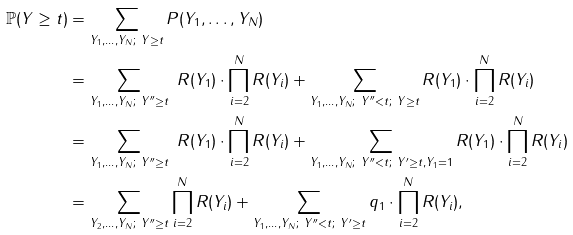<formula> <loc_0><loc_0><loc_500><loc_500>\mathbb { P } ( Y \geq t ) & = \sum _ { Y _ { 1 } , \dots , Y _ { N } ; \ Y \geq t } P ( Y _ { 1 } , \dots , Y _ { N } ) \\ & = \sum _ { Y _ { 1 } , \dots , Y _ { N } ; \ Y ^ { \prime \prime } \geq t } \ R ( Y _ { 1 } ) \cdot \prod _ { i = 2 } ^ { N } R ( Y _ { i } ) + \sum _ { Y _ { 1 } , \dots , Y _ { N } ; \ Y ^ { \prime \prime } < t ; \ Y \geq t } R ( Y _ { 1 } ) \cdot \prod _ { i = 2 } ^ { N } R ( Y _ { i } ) \\ & = \sum _ { Y _ { 1 } , \dots , Y _ { N } ; \ Y ^ { \prime \prime } \geq t } \ R ( Y _ { 1 } ) \cdot \prod _ { i = 2 } ^ { N } R ( Y _ { i } ) + \sum _ { Y _ { 1 } , \dots , Y _ { N } ; \ Y ^ { \prime \prime } < t ; \ Y ^ { \prime } \geq t , Y _ { 1 } = 1 } R ( Y _ { 1 } ) \cdot \prod _ { i = 2 } ^ { N } R ( Y _ { i } ) \\ & = \sum _ { Y _ { 2 } , \dots , Y _ { N } ; \ Y ^ { \prime \prime } \geq t } \prod _ { i = 2 } ^ { N } R ( Y _ { i } ) + \sum _ { Y _ { 1 } , \dots , Y _ { N } ; \ Y ^ { \prime \prime } < t ; \ Y ^ { \prime } \geq t } q _ { 1 } \cdot \prod _ { i = 2 } ^ { N } R ( Y _ { i } ) ,</formula> 